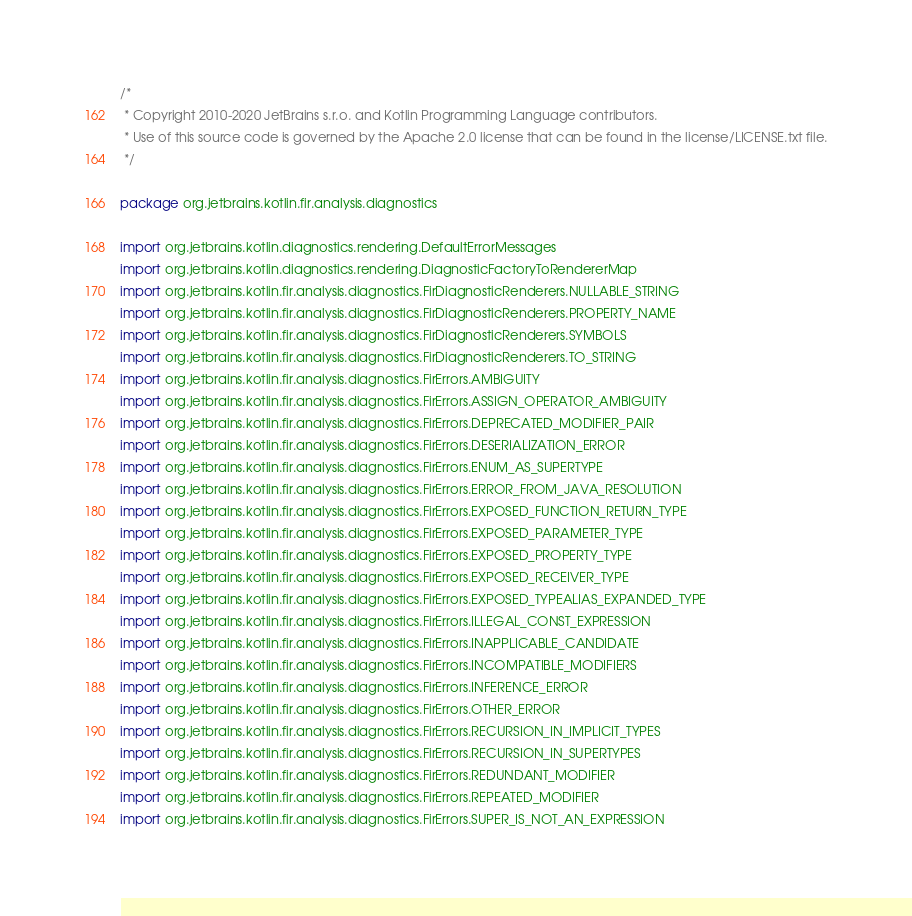<code> <loc_0><loc_0><loc_500><loc_500><_Kotlin_>/*
 * Copyright 2010-2020 JetBrains s.r.o. and Kotlin Programming Language contributors.
 * Use of this source code is governed by the Apache 2.0 license that can be found in the license/LICENSE.txt file.
 */

package org.jetbrains.kotlin.fir.analysis.diagnostics

import org.jetbrains.kotlin.diagnostics.rendering.DefaultErrorMessages
import org.jetbrains.kotlin.diagnostics.rendering.DiagnosticFactoryToRendererMap
import org.jetbrains.kotlin.fir.analysis.diagnostics.FirDiagnosticRenderers.NULLABLE_STRING
import org.jetbrains.kotlin.fir.analysis.diagnostics.FirDiagnosticRenderers.PROPERTY_NAME
import org.jetbrains.kotlin.fir.analysis.diagnostics.FirDiagnosticRenderers.SYMBOLS
import org.jetbrains.kotlin.fir.analysis.diagnostics.FirDiagnosticRenderers.TO_STRING
import org.jetbrains.kotlin.fir.analysis.diagnostics.FirErrors.AMBIGUITY
import org.jetbrains.kotlin.fir.analysis.diagnostics.FirErrors.ASSIGN_OPERATOR_AMBIGUITY
import org.jetbrains.kotlin.fir.analysis.diagnostics.FirErrors.DEPRECATED_MODIFIER_PAIR
import org.jetbrains.kotlin.fir.analysis.diagnostics.FirErrors.DESERIALIZATION_ERROR
import org.jetbrains.kotlin.fir.analysis.diagnostics.FirErrors.ENUM_AS_SUPERTYPE
import org.jetbrains.kotlin.fir.analysis.diagnostics.FirErrors.ERROR_FROM_JAVA_RESOLUTION
import org.jetbrains.kotlin.fir.analysis.diagnostics.FirErrors.EXPOSED_FUNCTION_RETURN_TYPE
import org.jetbrains.kotlin.fir.analysis.diagnostics.FirErrors.EXPOSED_PARAMETER_TYPE
import org.jetbrains.kotlin.fir.analysis.diagnostics.FirErrors.EXPOSED_PROPERTY_TYPE
import org.jetbrains.kotlin.fir.analysis.diagnostics.FirErrors.EXPOSED_RECEIVER_TYPE
import org.jetbrains.kotlin.fir.analysis.diagnostics.FirErrors.EXPOSED_TYPEALIAS_EXPANDED_TYPE
import org.jetbrains.kotlin.fir.analysis.diagnostics.FirErrors.ILLEGAL_CONST_EXPRESSION
import org.jetbrains.kotlin.fir.analysis.diagnostics.FirErrors.INAPPLICABLE_CANDIDATE
import org.jetbrains.kotlin.fir.analysis.diagnostics.FirErrors.INCOMPATIBLE_MODIFIERS
import org.jetbrains.kotlin.fir.analysis.diagnostics.FirErrors.INFERENCE_ERROR
import org.jetbrains.kotlin.fir.analysis.diagnostics.FirErrors.OTHER_ERROR
import org.jetbrains.kotlin.fir.analysis.diagnostics.FirErrors.RECURSION_IN_IMPLICIT_TYPES
import org.jetbrains.kotlin.fir.analysis.diagnostics.FirErrors.RECURSION_IN_SUPERTYPES
import org.jetbrains.kotlin.fir.analysis.diagnostics.FirErrors.REDUNDANT_MODIFIER
import org.jetbrains.kotlin.fir.analysis.diagnostics.FirErrors.REPEATED_MODIFIER
import org.jetbrains.kotlin.fir.analysis.diagnostics.FirErrors.SUPER_IS_NOT_AN_EXPRESSION</code> 